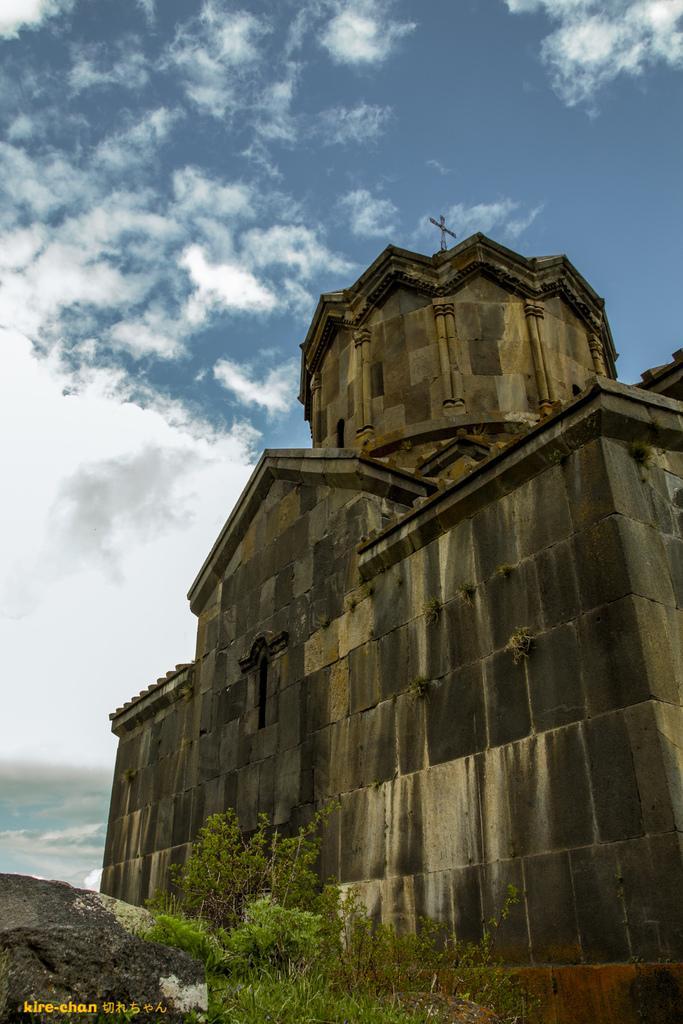Describe this image in one or two sentences. In the image there is a castle on the right side with plants in front of it and above its sky with clouds. 